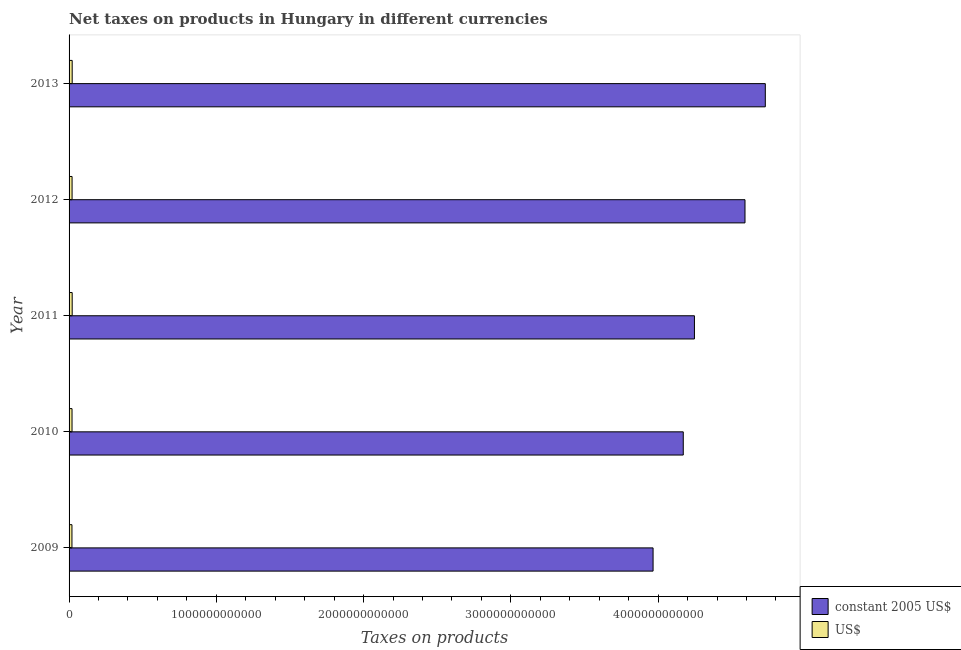Are the number of bars on each tick of the Y-axis equal?
Your answer should be very brief. Yes. How many bars are there on the 1st tick from the top?
Your answer should be compact. 2. How many bars are there on the 2nd tick from the bottom?
Your answer should be compact. 2. What is the label of the 2nd group of bars from the top?
Your answer should be compact. 2012. In how many cases, is the number of bars for a given year not equal to the number of legend labels?
Your answer should be compact. 0. What is the net taxes in us$ in 2009?
Your answer should be very brief. 1.96e+1. Across all years, what is the maximum net taxes in us$?
Your response must be concise. 2.11e+1. Across all years, what is the minimum net taxes in us$?
Your response must be concise. 1.96e+1. What is the total net taxes in constant 2005 us$ in the graph?
Your answer should be compact. 2.17e+13. What is the difference between the net taxes in us$ in 2010 and that in 2013?
Keep it short and to the point. -1.08e+09. What is the difference between the net taxes in constant 2005 us$ in 2009 and the net taxes in us$ in 2012?
Provide a succinct answer. 3.95e+12. What is the average net taxes in constant 2005 us$ per year?
Provide a succinct answer. 4.34e+12. In the year 2011, what is the difference between the net taxes in constant 2005 us$ and net taxes in us$?
Offer a very short reply. 4.23e+12. In how many years, is the net taxes in us$ greater than 400000000000 units?
Provide a short and direct response. 0. Is the difference between the net taxes in us$ in 2010 and 2011 greater than the difference between the net taxes in constant 2005 us$ in 2010 and 2011?
Ensure brevity in your answer.  Yes. What is the difference between the highest and the second highest net taxes in us$?
Provide a short and direct response. 1.37e+07. What is the difference between the highest and the lowest net taxes in us$?
Offer a very short reply. 1.54e+09. In how many years, is the net taxes in us$ greater than the average net taxes in us$ taken over all years?
Provide a short and direct response. 2. Is the sum of the net taxes in constant 2005 us$ in 2010 and 2012 greater than the maximum net taxes in us$ across all years?
Offer a terse response. Yes. What does the 1st bar from the top in 2011 represents?
Your response must be concise. US$. What does the 1st bar from the bottom in 2009 represents?
Provide a succinct answer. Constant 2005 us$. How many bars are there?
Provide a short and direct response. 10. How many years are there in the graph?
Offer a terse response. 5. What is the difference between two consecutive major ticks on the X-axis?
Offer a terse response. 1.00e+12. Are the values on the major ticks of X-axis written in scientific E-notation?
Offer a very short reply. No. Does the graph contain any zero values?
Keep it short and to the point. No. Does the graph contain grids?
Keep it short and to the point. No. How are the legend labels stacked?
Make the answer very short. Vertical. What is the title of the graph?
Ensure brevity in your answer.  Net taxes on products in Hungary in different currencies. What is the label or title of the X-axis?
Offer a terse response. Taxes on products. What is the Taxes on products in constant 2005 US$ in 2009?
Your answer should be compact. 3.97e+12. What is the Taxes on products in US$ in 2009?
Give a very brief answer. 1.96e+1. What is the Taxes on products of constant 2005 US$ in 2010?
Your answer should be compact. 4.17e+12. What is the Taxes on products in US$ in 2010?
Offer a terse response. 2.01e+1. What is the Taxes on products of constant 2005 US$ in 2011?
Offer a very short reply. 4.25e+12. What is the Taxes on products of US$ in 2011?
Keep it short and to the point. 2.11e+1. What is the Taxes on products in constant 2005 US$ in 2012?
Keep it short and to the point. 4.59e+12. What is the Taxes on products in US$ in 2012?
Your answer should be very brief. 2.04e+1. What is the Taxes on products in constant 2005 US$ in 2013?
Ensure brevity in your answer.  4.73e+12. What is the Taxes on products of US$ in 2013?
Give a very brief answer. 2.11e+1. Across all years, what is the maximum Taxes on products in constant 2005 US$?
Offer a very short reply. 4.73e+12. Across all years, what is the maximum Taxes on products in US$?
Offer a very short reply. 2.11e+1. Across all years, what is the minimum Taxes on products in constant 2005 US$?
Give a very brief answer. 3.97e+12. Across all years, what is the minimum Taxes on products of US$?
Offer a terse response. 1.96e+1. What is the total Taxes on products of constant 2005 US$ in the graph?
Provide a succinct answer. 2.17e+13. What is the total Taxes on products of US$ in the graph?
Your answer should be compact. 1.02e+11. What is the difference between the Taxes on products of constant 2005 US$ in 2009 and that in 2010?
Your response must be concise. -2.05e+11. What is the difference between the Taxes on products of US$ in 2009 and that in 2010?
Ensure brevity in your answer.  -4.58e+08. What is the difference between the Taxes on products in constant 2005 US$ in 2009 and that in 2011?
Provide a succinct answer. -2.81e+11. What is the difference between the Taxes on products of US$ in 2009 and that in 2011?
Provide a short and direct response. -1.52e+09. What is the difference between the Taxes on products in constant 2005 US$ in 2009 and that in 2012?
Keep it short and to the point. -6.24e+11. What is the difference between the Taxes on products of US$ in 2009 and that in 2012?
Ensure brevity in your answer.  -7.91e+08. What is the difference between the Taxes on products in constant 2005 US$ in 2009 and that in 2013?
Offer a terse response. -7.62e+11. What is the difference between the Taxes on products in US$ in 2009 and that in 2013?
Your answer should be very brief. -1.54e+09. What is the difference between the Taxes on products in constant 2005 US$ in 2010 and that in 2011?
Offer a very short reply. -7.59e+1. What is the difference between the Taxes on products in US$ in 2010 and that in 2011?
Offer a very short reply. -1.06e+09. What is the difference between the Taxes on products in constant 2005 US$ in 2010 and that in 2012?
Offer a very short reply. -4.19e+11. What is the difference between the Taxes on products in US$ in 2010 and that in 2012?
Make the answer very short. -3.33e+08. What is the difference between the Taxes on products in constant 2005 US$ in 2010 and that in 2013?
Your answer should be compact. -5.57e+11. What is the difference between the Taxes on products in US$ in 2010 and that in 2013?
Your answer should be very brief. -1.08e+09. What is the difference between the Taxes on products in constant 2005 US$ in 2011 and that in 2012?
Give a very brief answer. -3.43e+11. What is the difference between the Taxes on products of US$ in 2011 and that in 2012?
Keep it short and to the point. 7.31e+08. What is the difference between the Taxes on products of constant 2005 US$ in 2011 and that in 2013?
Keep it short and to the point. -4.81e+11. What is the difference between the Taxes on products of US$ in 2011 and that in 2013?
Make the answer very short. -1.37e+07. What is the difference between the Taxes on products of constant 2005 US$ in 2012 and that in 2013?
Keep it short and to the point. -1.38e+11. What is the difference between the Taxes on products of US$ in 2012 and that in 2013?
Provide a succinct answer. -7.45e+08. What is the difference between the Taxes on products of constant 2005 US$ in 2009 and the Taxes on products of US$ in 2010?
Your answer should be very brief. 3.95e+12. What is the difference between the Taxes on products of constant 2005 US$ in 2009 and the Taxes on products of US$ in 2011?
Offer a terse response. 3.94e+12. What is the difference between the Taxes on products in constant 2005 US$ in 2009 and the Taxes on products in US$ in 2012?
Provide a succinct answer. 3.95e+12. What is the difference between the Taxes on products of constant 2005 US$ in 2009 and the Taxes on products of US$ in 2013?
Your answer should be very brief. 3.94e+12. What is the difference between the Taxes on products of constant 2005 US$ in 2010 and the Taxes on products of US$ in 2011?
Your answer should be very brief. 4.15e+12. What is the difference between the Taxes on products in constant 2005 US$ in 2010 and the Taxes on products in US$ in 2012?
Keep it short and to the point. 4.15e+12. What is the difference between the Taxes on products of constant 2005 US$ in 2010 and the Taxes on products of US$ in 2013?
Provide a succinct answer. 4.15e+12. What is the difference between the Taxes on products of constant 2005 US$ in 2011 and the Taxes on products of US$ in 2012?
Provide a short and direct response. 4.23e+12. What is the difference between the Taxes on products in constant 2005 US$ in 2011 and the Taxes on products in US$ in 2013?
Provide a succinct answer. 4.23e+12. What is the difference between the Taxes on products of constant 2005 US$ in 2012 and the Taxes on products of US$ in 2013?
Provide a short and direct response. 4.57e+12. What is the average Taxes on products of constant 2005 US$ per year?
Make the answer very short. 4.34e+12. What is the average Taxes on products in US$ per year?
Your response must be concise. 2.05e+1. In the year 2009, what is the difference between the Taxes on products of constant 2005 US$ and Taxes on products of US$?
Your answer should be compact. 3.95e+12. In the year 2010, what is the difference between the Taxes on products of constant 2005 US$ and Taxes on products of US$?
Make the answer very short. 4.15e+12. In the year 2011, what is the difference between the Taxes on products in constant 2005 US$ and Taxes on products in US$?
Provide a succinct answer. 4.23e+12. In the year 2012, what is the difference between the Taxes on products of constant 2005 US$ and Taxes on products of US$?
Keep it short and to the point. 4.57e+12. In the year 2013, what is the difference between the Taxes on products of constant 2005 US$ and Taxes on products of US$?
Give a very brief answer. 4.71e+12. What is the ratio of the Taxes on products of constant 2005 US$ in 2009 to that in 2010?
Keep it short and to the point. 0.95. What is the ratio of the Taxes on products in US$ in 2009 to that in 2010?
Keep it short and to the point. 0.98. What is the ratio of the Taxes on products in constant 2005 US$ in 2009 to that in 2011?
Your answer should be compact. 0.93. What is the ratio of the Taxes on products of US$ in 2009 to that in 2011?
Offer a terse response. 0.93. What is the ratio of the Taxes on products of constant 2005 US$ in 2009 to that in 2012?
Make the answer very short. 0.86. What is the ratio of the Taxes on products of US$ in 2009 to that in 2012?
Give a very brief answer. 0.96. What is the ratio of the Taxes on products in constant 2005 US$ in 2009 to that in 2013?
Ensure brevity in your answer.  0.84. What is the ratio of the Taxes on products in US$ in 2009 to that in 2013?
Your answer should be compact. 0.93. What is the ratio of the Taxes on products of constant 2005 US$ in 2010 to that in 2011?
Provide a succinct answer. 0.98. What is the ratio of the Taxes on products in US$ in 2010 to that in 2011?
Offer a terse response. 0.95. What is the ratio of the Taxes on products in constant 2005 US$ in 2010 to that in 2012?
Offer a very short reply. 0.91. What is the ratio of the Taxes on products in US$ in 2010 to that in 2012?
Ensure brevity in your answer.  0.98. What is the ratio of the Taxes on products of constant 2005 US$ in 2010 to that in 2013?
Your answer should be compact. 0.88. What is the ratio of the Taxes on products in US$ in 2010 to that in 2013?
Your answer should be very brief. 0.95. What is the ratio of the Taxes on products in constant 2005 US$ in 2011 to that in 2012?
Your answer should be very brief. 0.93. What is the ratio of the Taxes on products of US$ in 2011 to that in 2012?
Provide a short and direct response. 1.04. What is the ratio of the Taxes on products in constant 2005 US$ in 2011 to that in 2013?
Make the answer very short. 0.9. What is the ratio of the Taxes on products of US$ in 2011 to that in 2013?
Ensure brevity in your answer.  1. What is the ratio of the Taxes on products of constant 2005 US$ in 2012 to that in 2013?
Make the answer very short. 0.97. What is the ratio of the Taxes on products of US$ in 2012 to that in 2013?
Your answer should be compact. 0.96. What is the difference between the highest and the second highest Taxes on products of constant 2005 US$?
Your response must be concise. 1.38e+11. What is the difference between the highest and the second highest Taxes on products in US$?
Provide a short and direct response. 1.37e+07. What is the difference between the highest and the lowest Taxes on products in constant 2005 US$?
Provide a succinct answer. 7.62e+11. What is the difference between the highest and the lowest Taxes on products in US$?
Make the answer very short. 1.54e+09. 